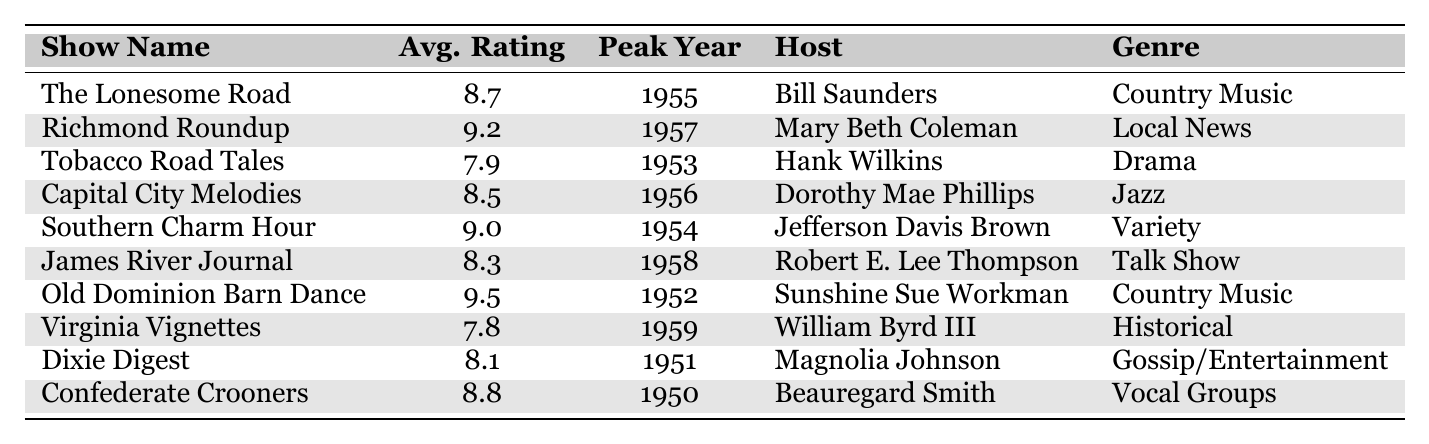What is the average rating of "Richmond Roundup"? The average rating of "Richmond Roundup" is directly listed in the table under the column "Avg. Rating", which shows 9.2.
Answer: 9.2 Which show aired in peak year 1954? The table indicates that "Southern Charm Hour" aired in the peak year of 1954, as seen in the "Peak Year" column.
Answer: Southern Charm Hour What is the genre of "Old Dominion Barn Dance"? The genre for "Old Dominion Barn Dance" is found in the "Genre" column, which states it is "Country Music."
Answer: Country Music Who hosted "Tobacco Road Tales"? According to the table, the host of "Tobacco Road Tales" is Hank Wilkins, as listed in the "Host" column.
Answer: Hank Wilkins Which two shows have an average rating above 9.0? "Richmond Roundup" (9.2) and "Old Dominion Barn Dance" (9.5) both have ratings above 9.0, found in the "Avg. Rating" column.
Answer: Richmond Roundup, Old Dominion Barn Dance What is the difference in average ratings between "Virginia Vignettes" and "Dixie Digest"? "Virginia Vignettes" rated 7.8 and "Dixie Digest" rated 8.1, so the difference is 8.1 - 7.8 = 0.3.
Answer: 0.3 Is there a show hosted by a female in the list? Yes, "Richmond Roundup" (hosted by Mary Beth Coleman) and "Capital City Melodies" (hosted by Dorothy Mae Phillips) are shows hosted by females, confirming there are female hosts present.
Answer: Yes Which genre has the highest average rating? To find this, average the ratings for all shows in the same genre. "Country Music" has two entries: (8.7 + 9.5) / 2 = 9.1. "Local News" and "Variety" average 9.2 and 9.0 respectively; all others average lower. Thus, "Country Music" has the highest average rating.
Answer: Country Music What is the lowest-rated show and its rating? The lowest rating recorded in the "Avg. Rating" column is 7.8 for "Virginia Vignettes".
Answer: Virginia Vignettes, 7.8 Which host had the highest-rated show? The host of the highest-rated show, "Old Dominion Barn Dance," is Sunshine Sue Workman, with a rating of 9.5.
Answer: Sunshine Sue Workman 